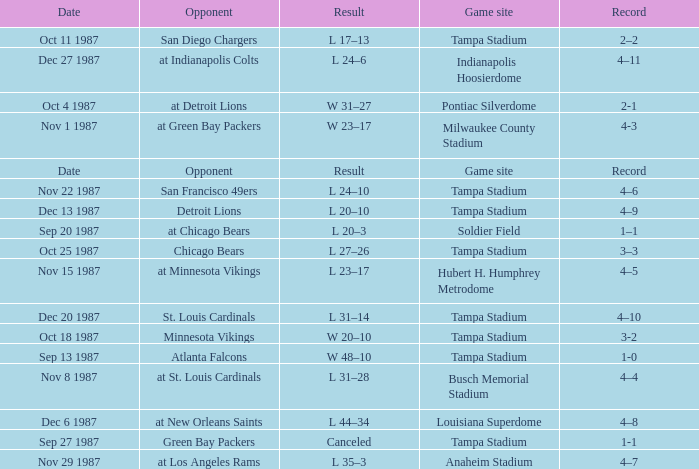Who was the Opponent at the Game Site Indianapolis Hoosierdome? At indianapolis colts. I'm looking to parse the entire table for insights. Could you assist me with that? {'header': ['Date', 'Opponent', 'Result', 'Game site', 'Record'], 'rows': [['Oct 11 1987', 'San Diego Chargers', 'L 17–13', 'Tampa Stadium', '2–2'], ['Dec 27 1987', 'at Indianapolis Colts', 'L 24–6', 'Indianapolis Hoosierdome', '4–11'], ['Oct 4 1987', 'at Detroit Lions', 'W 31–27', 'Pontiac Silverdome', '2-1'], ['Nov 1 1987', 'at Green Bay Packers', 'W 23–17', 'Milwaukee County Stadium', '4-3'], ['Date', 'Opponent', 'Result', 'Game site', 'Record'], ['Nov 22 1987', 'San Francisco 49ers', 'L 24–10', 'Tampa Stadium', '4–6'], ['Dec 13 1987', 'Detroit Lions', 'L 20–10', 'Tampa Stadium', '4–9'], ['Sep 20 1987', 'at Chicago Bears', 'L 20–3', 'Soldier Field', '1–1'], ['Oct 25 1987', 'Chicago Bears', 'L 27–26', 'Tampa Stadium', '3–3'], ['Nov 15 1987', 'at Minnesota Vikings', 'L 23–17', 'Hubert H. Humphrey Metrodome', '4–5'], ['Dec 20 1987', 'St. Louis Cardinals', 'L 31–14', 'Tampa Stadium', '4–10'], ['Oct 18 1987', 'Minnesota Vikings', 'W 20–10', 'Tampa Stadium', '3-2'], ['Sep 13 1987', 'Atlanta Falcons', 'W 48–10', 'Tampa Stadium', '1-0'], ['Nov 8 1987', 'at St. Louis Cardinals', 'L 31–28', 'Busch Memorial Stadium', '4–4'], ['Dec 6 1987', 'at New Orleans Saints', 'L 44–34', 'Louisiana Superdome', '4–8'], ['Sep 27 1987', 'Green Bay Packers', 'Canceled', 'Tampa Stadium', '1-1'], ['Nov 29 1987', 'at Los Angeles Rams', 'L 35–3', 'Anaheim Stadium', '4–7']]} 